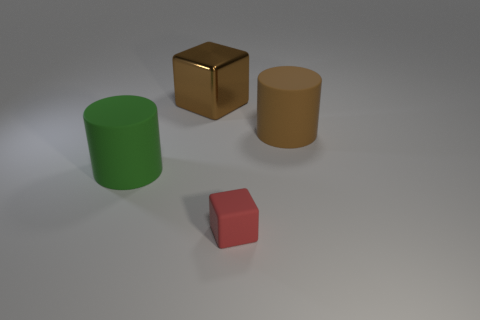Add 2 small rubber cubes. How many objects exist? 6 Subtract all large shiny cubes. Subtract all small brown metal things. How many objects are left? 3 Add 3 red rubber things. How many red rubber things are left? 4 Add 4 tiny blue shiny cylinders. How many tiny blue shiny cylinders exist? 4 Subtract 0 yellow spheres. How many objects are left? 4 